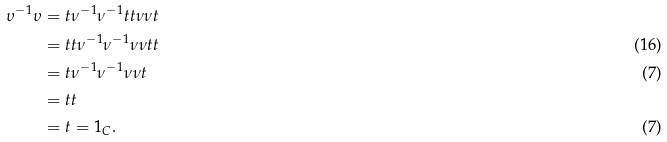<formula> <loc_0><loc_0><loc_500><loc_500>\upsilon ^ { - 1 } \upsilon & = t \nu ^ { - 1 } \nu ^ { - 1 } t t \nu \nu t \\ & = t t \nu ^ { - 1 } \nu ^ { - 1 } \nu \nu t t & \text {(16)} \\ & = t \nu ^ { - 1 } \nu ^ { - 1 } \nu \nu t & \text {(7)} \\ & = t t \\ & = t = 1 _ { C } . & \text {(7)}</formula> 